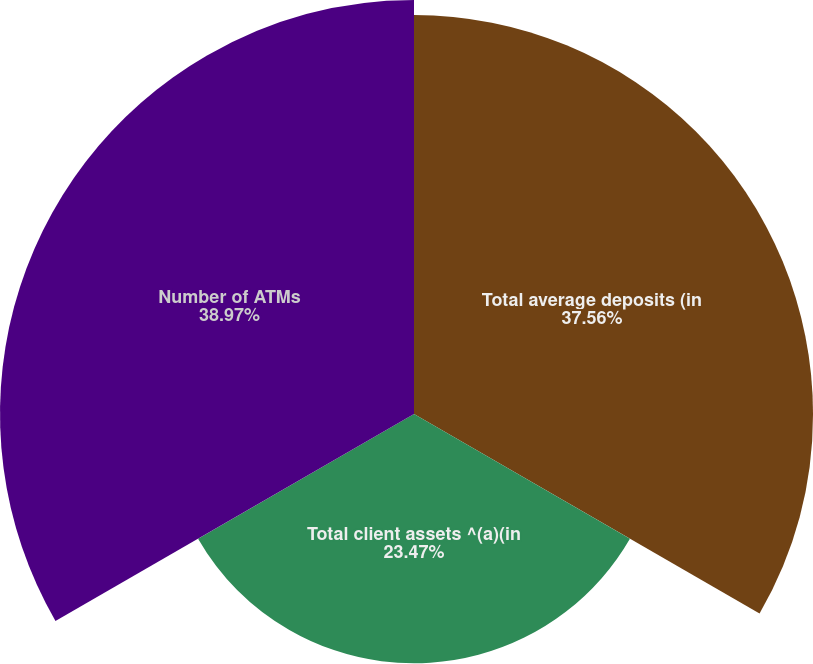Convert chart. <chart><loc_0><loc_0><loc_500><loc_500><pie_chart><fcel>Total average deposits (in<fcel>Total client assets ^(a)(in<fcel>Number of ATMs<nl><fcel>37.56%<fcel>23.47%<fcel>38.97%<nl></chart> 